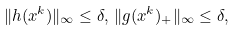<formula> <loc_0><loc_0><loc_500><loc_500>\| h ( x ^ { k } ) \| _ { \infty } \leq \delta , \, \| g ( x ^ { k } ) _ { + } \| _ { \infty } \leq \delta ,</formula> 